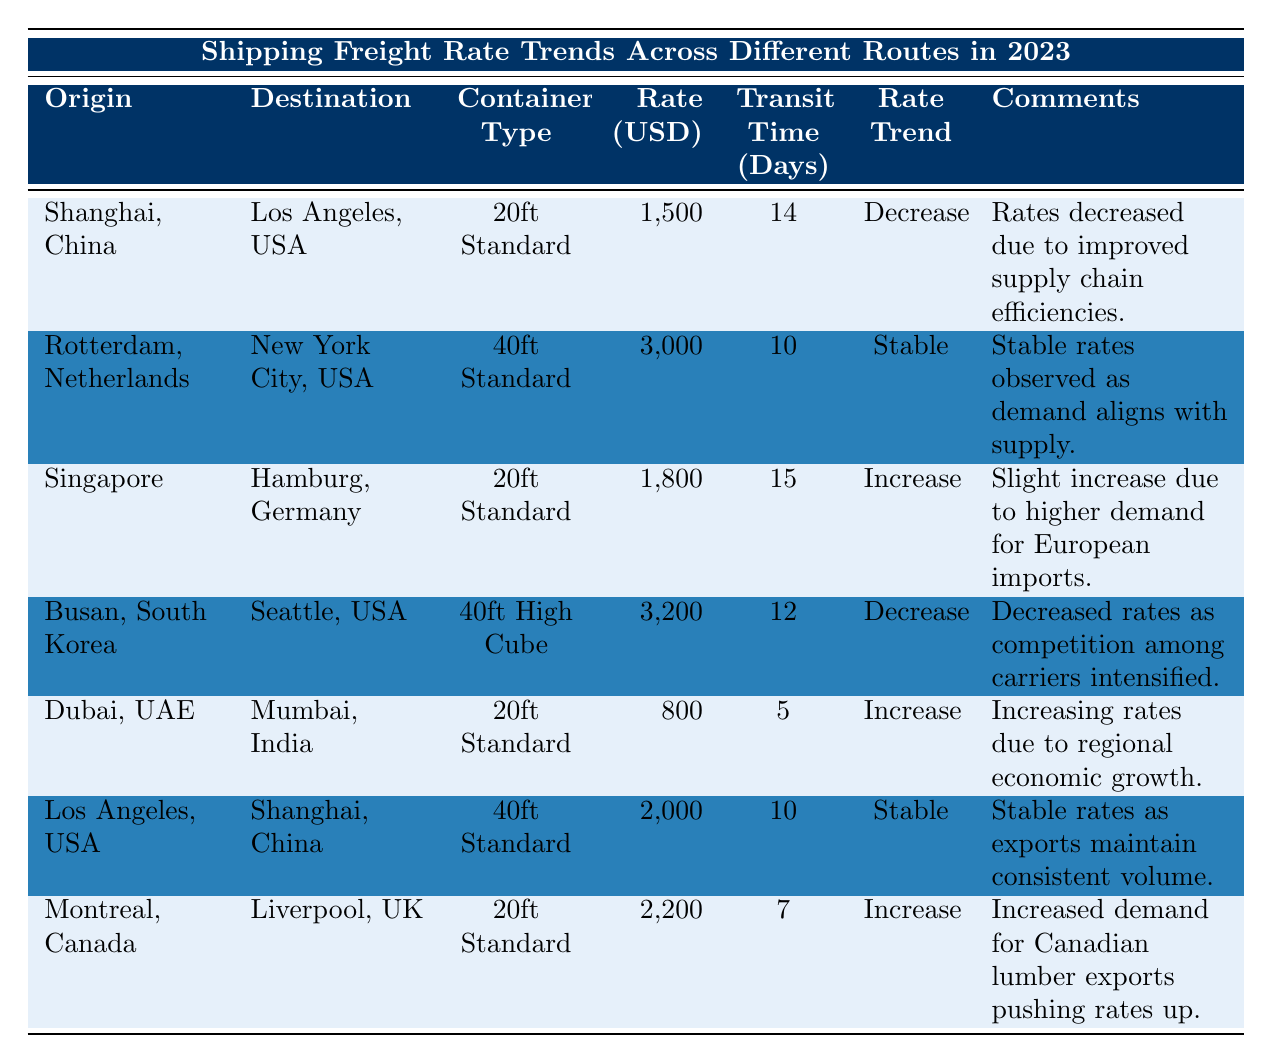What is the shipping rate from Shanghai, China to Los Angeles, USA? The table lists the shipping rate for the route from Shanghai, China to Los Angeles, USA as 1,500 USD.
Answer: 1,500 USD What is the average transit time for shipping from Rotterdam, Netherlands to New York City, USA? The average transit time for the route from Rotterdam, Netherlands to New York City, USA is 10 days, as specified in the table.
Answer: 10 days Which route has the highest shipping rate in 2023? The table shows that the route from Busan, South Korea to Seattle, USA has the highest shipping rate at 3,200 USD.
Answer: 3,200 USD How many routes show an increase in shipping rates? Upon reviewing the table, there are three routes that indicate an increase in shipping rates: Dubai to Mumbai, Singapore to Hamburg, and Montreal to Liverpool.
Answer: 3 What is the difference in shipping rates between the route from Busan, South Korea to Seattle, USA and the route from Dubai, UAE to Mumbai, India? The shipping rate from Busan to Seattle is 3,200 USD, and from Dubai to Mumbai is 800 USD. The difference is 3,200 - 800 = 2,400 USD.
Answer: 2,400 USD Is the shipping rate for the 20ft Standard container type from Singapore to Hamburg increasing? Yes, the table notes that the rate for this route is trending upwards, indicating an increase.
Answer: Yes What is the average shipping rate for all routes listed in the table? To calculate the average rate: (1,500 + 3,000 + 1,800 + 3,200 + 800 + 2,000 + 2,200) / 7 = 1,885.71 USD, rounding to two decimal places gives 1,885.71 as the average rate.
Answer: 1,885.71 USD Which route has a stable rate in shipping? The routes with stable rates in shipping are from Rotterdam, Netherlands to New York City, USA and from Los Angeles, USA to Shanghai, China.
Answer: 2 routes What is the shipping rate trend for the route from Montreal, Canada to Liverpool, UK? The table indicates that the rate trend for this route is an increase, due to higher demand for Canadian exports.
Answer: Increase Which route has the shortest average transit time? The route from Dubai, UAE to Mumbai, India has the shortest average transit time of 5 days, according to the table.
Answer: 5 days 